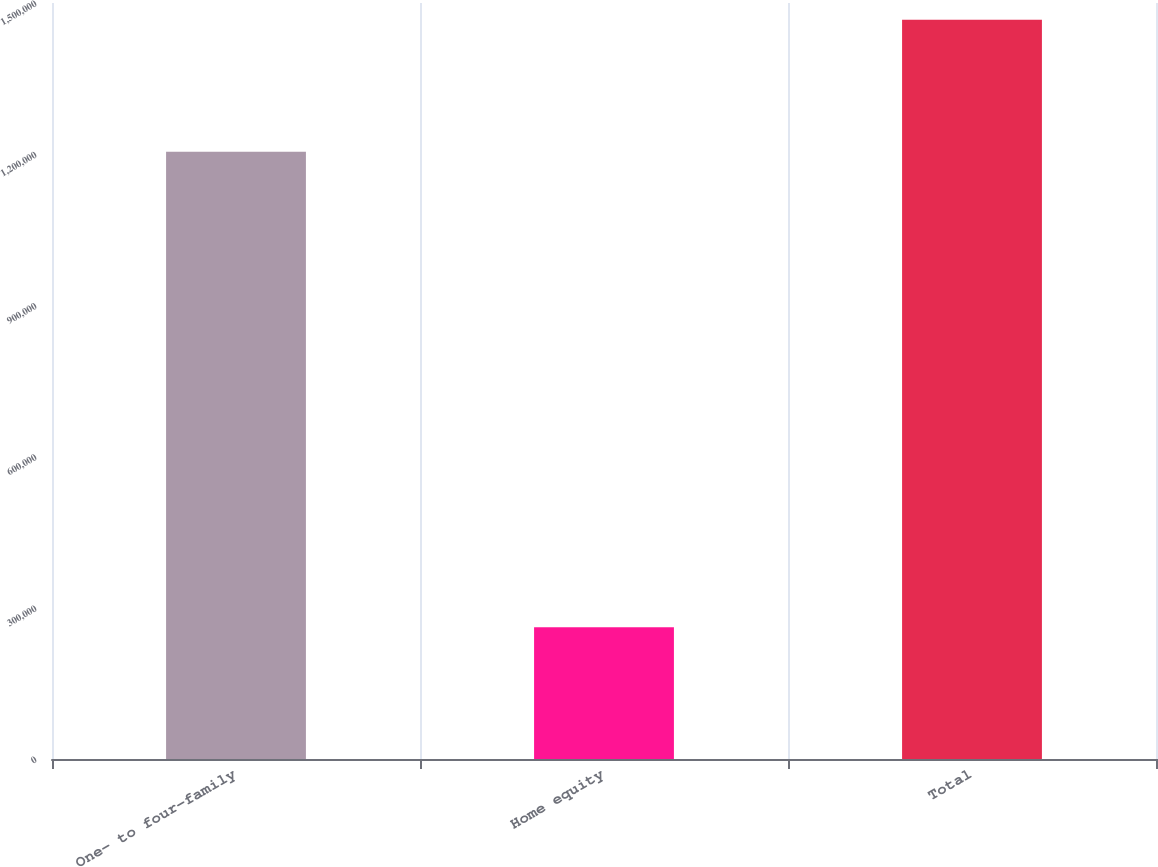Convert chart to OTSL. <chart><loc_0><loc_0><loc_500><loc_500><bar_chart><fcel>One- to four-family<fcel>Home equity<fcel>Total<nl><fcel>1.20502e+06<fcel>261533<fcel>1.46656e+06<nl></chart> 